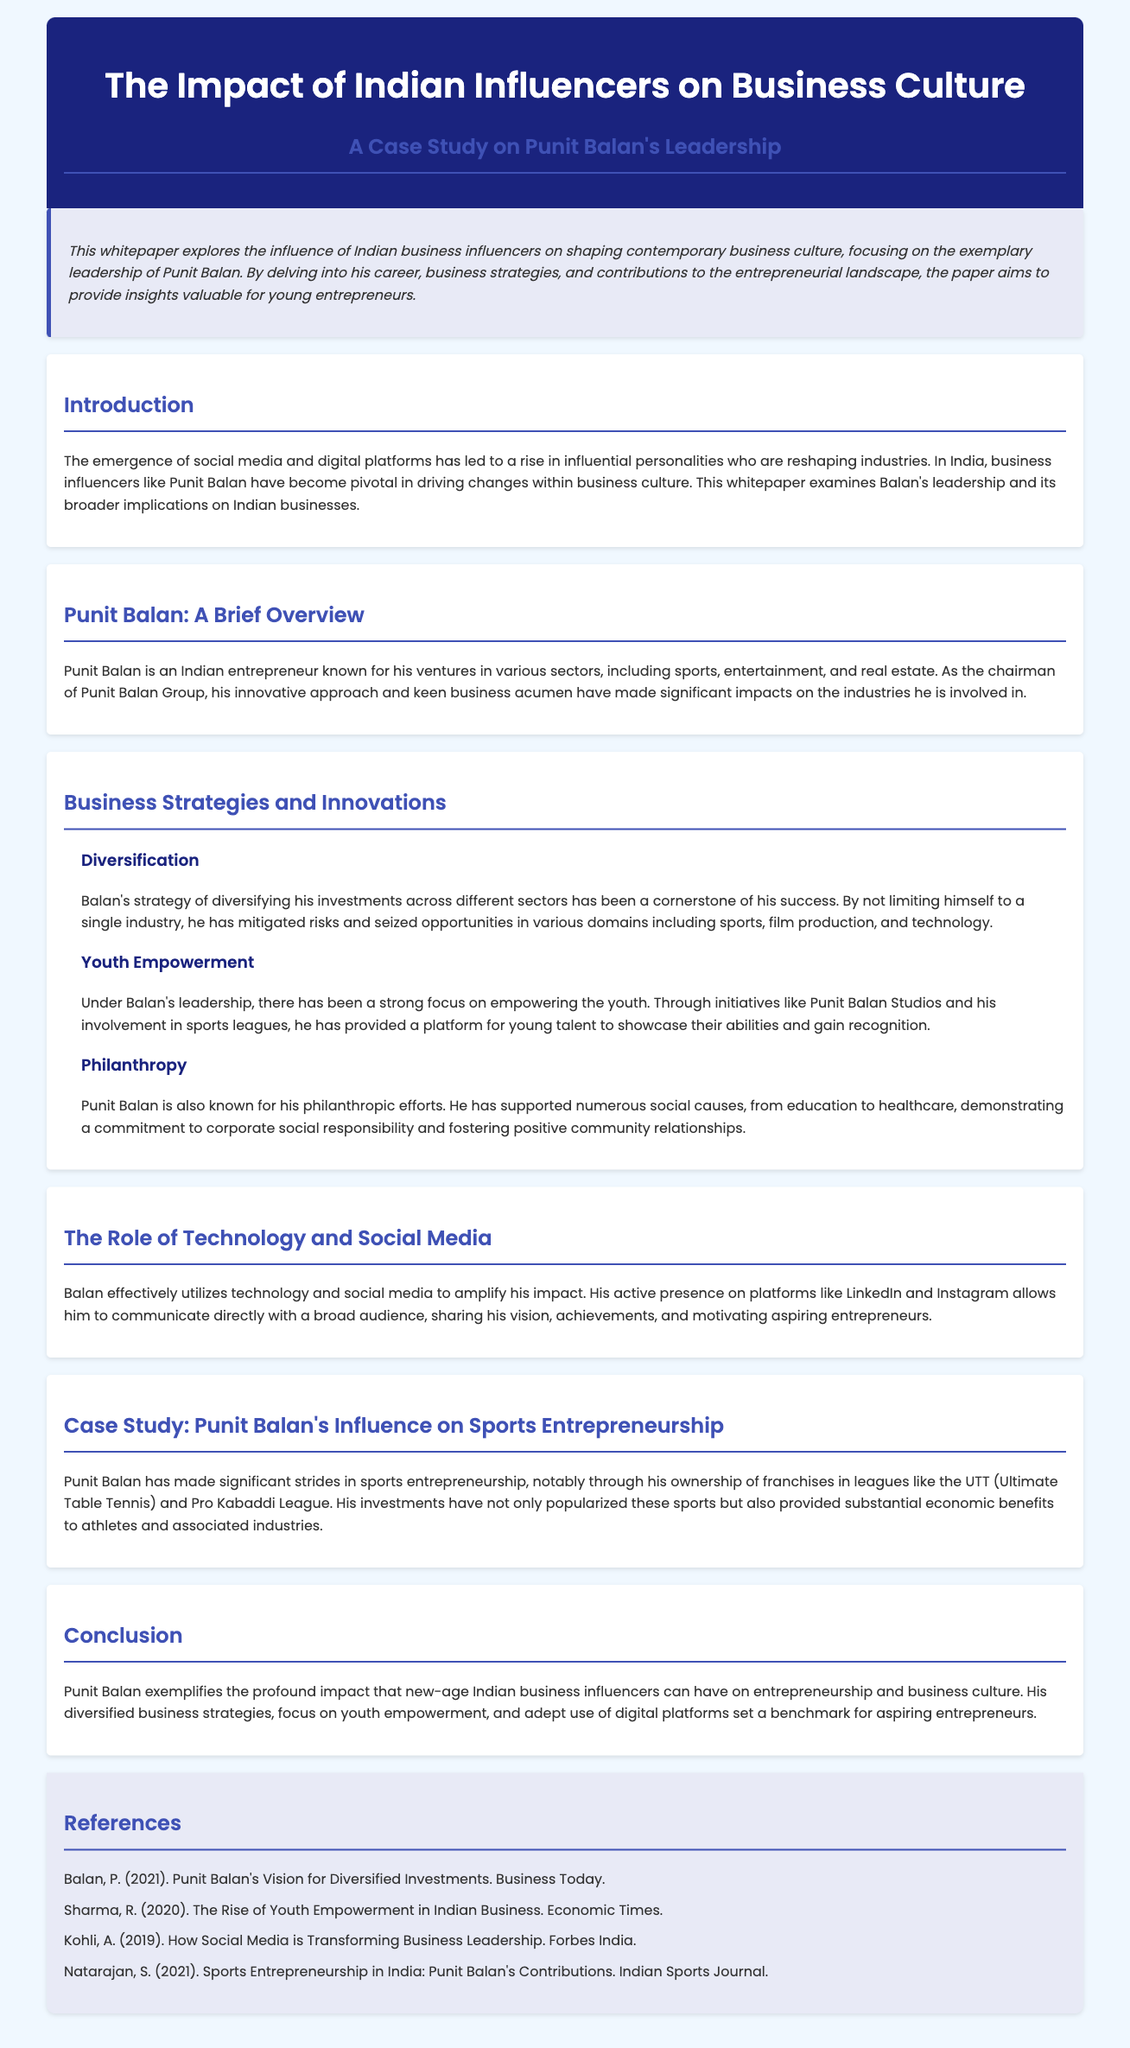What is the main focus of the whitepaper? The whitepaper examines the influence of Indian business influencers on shaping contemporary business culture, focusing on Punit Balan's leadership.
Answer: Punit Balan's leadership What sectors is Punit Balan known for? The document mentions various sectors where Punit Balan is involved, including sports, entertainment, and real estate.
Answer: Sports, entertainment, real estate What strategy has been a cornerstone of Balan's success? The strategy discussed regarding Balan's success is diversification of investments across different sectors.
Answer: Diversification Which initiative does Balan support for youth empowerment? The whitepaper highlights Punit Balan Studios as an initiative supporting youth empowerment.
Answer: Punit Balan Studios What type of leagues has Punit Balan invested in? The leagues mentioned in the document where Balan has significant investments include UTT and Pro Kabaddi League.
Answer: UTT and Pro Kabaddi League What role does technology and social media play in Balan's impact? Balan's effective use of technology and social media amplifies his influence and allows direct communication with audiences.
Answer: Amplifies influence Which philanthropic efforts is Punit Balan known for? Balan is known for supporting various social causes such as education and healthcare.
Answer: Education and healthcare What is the conclusion about Balan's influence? The conclusion states that Balan exemplifies the impact that new-age Indian business influencers can have on entrepreneurship and business culture.
Answer: Impact on entrepreneurship and business culture 